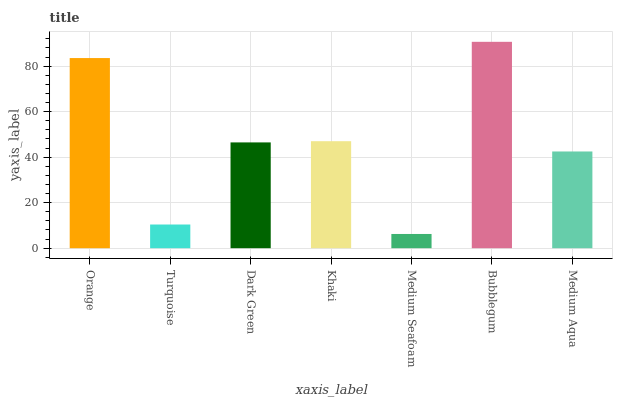Is Medium Seafoam the minimum?
Answer yes or no. Yes. Is Bubblegum the maximum?
Answer yes or no. Yes. Is Turquoise the minimum?
Answer yes or no. No. Is Turquoise the maximum?
Answer yes or no. No. Is Orange greater than Turquoise?
Answer yes or no. Yes. Is Turquoise less than Orange?
Answer yes or no. Yes. Is Turquoise greater than Orange?
Answer yes or no. No. Is Orange less than Turquoise?
Answer yes or no. No. Is Dark Green the high median?
Answer yes or no. Yes. Is Dark Green the low median?
Answer yes or no. Yes. Is Medium Aqua the high median?
Answer yes or no. No. Is Medium Aqua the low median?
Answer yes or no. No. 